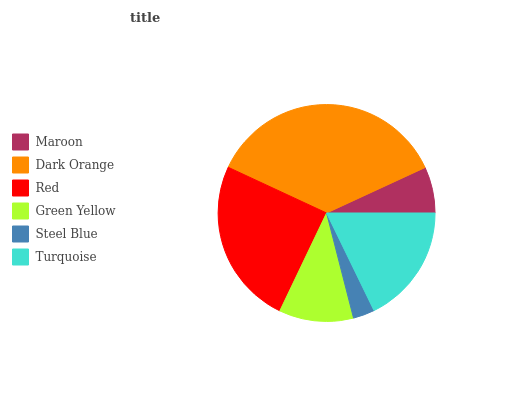Is Steel Blue the minimum?
Answer yes or no. Yes. Is Dark Orange the maximum?
Answer yes or no. Yes. Is Red the minimum?
Answer yes or no. No. Is Red the maximum?
Answer yes or no. No. Is Dark Orange greater than Red?
Answer yes or no. Yes. Is Red less than Dark Orange?
Answer yes or no. Yes. Is Red greater than Dark Orange?
Answer yes or no. No. Is Dark Orange less than Red?
Answer yes or no. No. Is Turquoise the high median?
Answer yes or no. Yes. Is Green Yellow the low median?
Answer yes or no. Yes. Is Maroon the high median?
Answer yes or no. No. Is Steel Blue the low median?
Answer yes or no. No. 